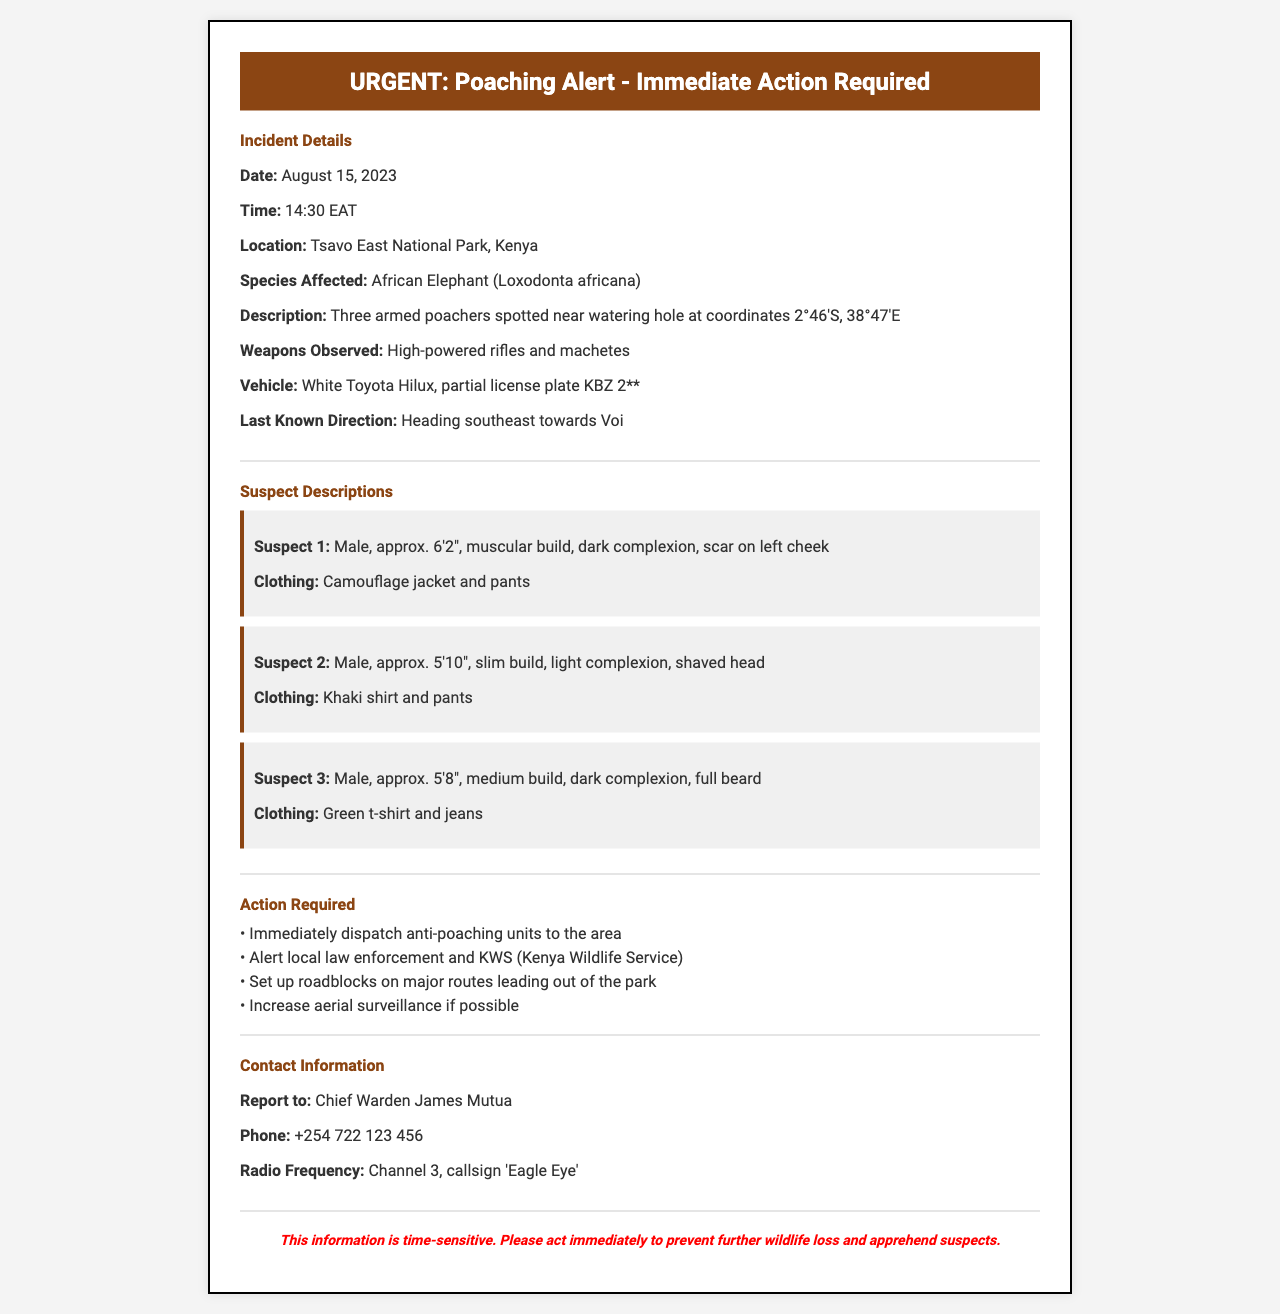What is the date of the poaching incident? The poaching incident occurred on August 15, 2023, as stated in the document.
Answer: August 15, 2023 What type of animal is affected by the poaching? The document specifies that the species affected is the African Elephant.
Answer: African Elephant How many suspects were reported? The document mentions three armed poachers were spotted, indicating the number of suspects.
Answer: Three What is the vehicle description associated with the suspects? The vehicle described in the document is a white Toyota Hilux with a partial license plate.
Answer: White Toyota Hilux What is the last known direction of the suspects? The document states that the suspects were last known to be heading southeast towards Voi.
Answer: Southeast towards Voi What weapons were observed with the suspects? The document details the weapons observed as high-powered rifles and machetes.
Answer: High-powered rifles and machetes Who should reports be directed to? The document indicates that reports should be directed to Chief Warden James Mutua.
Answer: Chief Warden James Mutua Which organization is alerted in the action required section? The document specifies that local law enforcement and KWS (Kenya Wildlife Service) need to be alerted.
Answer: KWS What is the urgency of the information? The document emphasizes that the information is time-sensitive and urges immediate action to prevent further wildlife loss.
Answer: Time-sensitive 